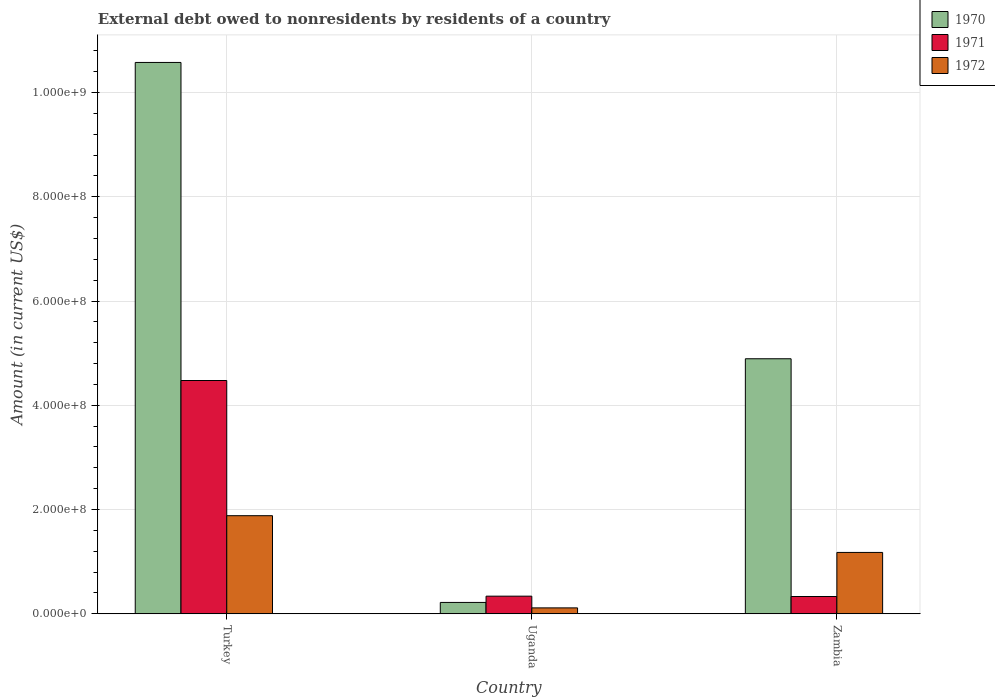How many different coloured bars are there?
Keep it short and to the point. 3. Are the number of bars on each tick of the X-axis equal?
Provide a succinct answer. Yes. What is the label of the 2nd group of bars from the left?
Your response must be concise. Uganda. What is the external debt owed by residents in 1971 in Turkey?
Offer a terse response. 4.48e+08. Across all countries, what is the maximum external debt owed by residents in 1972?
Offer a terse response. 1.88e+08. Across all countries, what is the minimum external debt owed by residents in 1970?
Keep it short and to the point. 2.18e+07. In which country was the external debt owed by residents in 1972 maximum?
Your answer should be compact. Turkey. In which country was the external debt owed by residents in 1972 minimum?
Offer a very short reply. Uganda. What is the total external debt owed by residents in 1972 in the graph?
Offer a terse response. 3.17e+08. What is the difference between the external debt owed by residents in 1971 in Turkey and that in Uganda?
Your answer should be very brief. 4.14e+08. What is the difference between the external debt owed by residents in 1971 in Zambia and the external debt owed by residents in 1970 in Uganda?
Keep it short and to the point. 1.14e+07. What is the average external debt owed by residents in 1971 per country?
Make the answer very short. 1.72e+08. What is the difference between the external debt owed by residents of/in 1970 and external debt owed by residents of/in 1971 in Uganda?
Provide a succinct answer. -1.20e+07. What is the ratio of the external debt owed by residents in 1970 in Turkey to that in Uganda?
Keep it short and to the point. 48.45. What is the difference between the highest and the second highest external debt owed by residents in 1970?
Make the answer very short. 5.68e+08. What is the difference between the highest and the lowest external debt owed by residents in 1972?
Keep it short and to the point. 1.77e+08. In how many countries, is the external debt owed by residents in 1970 greater than the average external debt owed by residents in 1970 taken over all countries?
Offer a very short reply. 1. What does the 2nd bar from the right in Zambia represents?
Your answer should be very brief. 1971. Are all the bars in the graph horizontal?
Keep it short and to the point. No. Are the values on the major ticks of Y-axis written in scientific E-notation?
Provide a short and direct response. Yes. Does the graph contain grids?
Your answer should be very brief. Yes. Where does the legend appear in the graph?
Provide a short and direct response. Top right. How many legend labels are there?
Provide a succinct answer. 3. What is the title of the graph?
Your response must be concise. External debt owed to nonresidents by residents of a country. Does "2013" appear as one of the legend labels in the graph?
Give a very brief answer. No. What is the Amount (in current US$) of 1970 in Turkey?
Give a very brief answer. 1.06e+09. What is the Amount (in current US$) of 1971 in Turkey?
Ensure brevity in your answer.  4.48e+08. What is the Amount (in current US$) in 1972 in Turkey?
Keep it short and to the point. 1.88e+08. What is the Amount (in current US$) of 1970 in Uganda?
Your answer should be compact. 2.18e+07. What is the Amount (in current US$) in 1971 in Uganda?
Offer a very short reply. 3.38e+07. What is the Amount (in current US$) in 1972 in Uganda?
Your answer should be compact. 1.14e+07. What is the Amount (in current US$) of 1970 in Zambia?
Offer a very short reply. 4.89e+08. What is the Amount (in current US$) of 1971 in Zambia?
Your response must be concise. 3.32e+07. What is the Amount (in current US$) of 1972 in Zambia?
Offer a terse response. 1.18e+08. Across all countries, what is the maximum Amount (in current US$) in 1970?
Provide a succinct answer. 1.06e+09. Across all countries, what is the maximum Amount (in current US$) in 1971?
Provide a succinct answer. 4.48e+08. Across all countries, what is the maximum Amount (in current US$) in 1972?
Provide a succinct answer. 1.88e+08. Across all countries, what is the minimum Amount (in current US$) of 1970?
Your answer should be very brief. 2.18e+07. Across all countries, what is the minimum Amount (in current US$) of 1971?
Your answer should be compact. 3.32e+07. Across all countries, what is the minimum Amount (in current US$) of 1972?
Give a very brief answer. 1.14e+07. What is the total Amount (in current US$) of 1970 in the graph?
Your response must be concise. 1.57e+09. What is the total Amount (in current US$) in 1971 in the graph?
Your response must be concise. 5.15e+08. What is the total Amount (in current US$) in 1972 in the graph?
Make the answer very short. 3.17e+08. What is the difference between the Amount (in current US$) in 1970 in Turkey and that in Uganda?
Provide a short and direct response. 1.04e+09. What is the difference between the Amount (in current US$) of 1971 in Turkey and that in Uganda?
Your response must be concise. 4.14e+08. What is the difference between the Amount (in current US$) of 1972 in Turkey and that in Uganda?
Your response must be concise. 1.77e+08. What is the difference between the Amount (in current US$) of 1970 in Turkey and that in Zambia?
Make the answer very short. 5.68e+08. What is the difference between the Amount (in current US$) of 1971 in Turkey and that in Zambia?
Your answer should be very brief. 4.14e+08. What is the difference between the Amount (in current US$) of 1972 in Turkey and that in Zambia?
Your answer should be compact. 7.05e+07. What is the difference between the Amount (in current US$) of 1970 in Uganda and that in Zambia?
Your answer should be very brief. -4.67e+08. What is the difference between the Amount (in current US$) of 1971 in Uganda and that in Zambia?
Your answer should be compact. 6.40e+05. What is the difference between the Amount (in current US$) in 1972 in Uganda and that in Zambia?
Keep it short and to the point. -1.06e+08. What is the difference between the Amount (in current US$) of 1970 in Turkey and the Amount (in current US$) of 1971 in Uganda?
Your answer should be very brief. 1.02e+09. What is the difference between the Amount (in current US$) in 1970 in Turkey and the Amount (in current US$) in 1972 in Uganda?
Make the answer very short. 1.05e+09. What is the difference between the Amount (in current US$) in 1971 in Turkey and the Amount (in current US$) in 1972 in Uganda?
Your answer should be very brief. 4.36e+08. What is the difference between the Amount (in current US$) in 1970 in Turkey and the Amount (in current US$) in 1971 in Zambia?
Your answer should be very brief. 1.02e+09. What is the difference between the Amount (in current US$) of 1970 in Turkey and the Amount (in current US$) of 1972 in Zambia?
Ensure brevity in your answer.  9.40e+08. What is the difference between the Amount (in current US$) in 1971 in Turkey and the Amount (in current US$) in 1972 in Zambia?
Keep it short and to the point. 3.30e+08. What is the difference between the Amount (in current US$) of 1970 in Uganda and the Amount (in current US$) of 1971 in Zambia?
Provide a succinct answer. -1.14e+07. What is the difference between the Amount (in current US$) of 1970 in Uganda and the Amount (in current US$) of 1972 in Zambia?
Your answer should be compact. -9.59e+07. What is the difference between the Amount (in current US$) of 1971 in Uganda and the Amount (in current US$) of 1972 in Zambia?
Make the answer very short. -8.39e+07. What is the average Amount (in current US$) of 1970 per country?
Offer a terse response. 5.23e+08. What is the average Amount (in current US$) of 1971 per country?
Offer a very short reply. 1.72e+08. What is the average Amount (in current US$) in 1972 per country?
Keep it short and to the point. 1.06e+08. What is the difference between the Amount (in current US$) of 1970 and Amount (in current US$) of 1971 in Turkey?
Make the answer very short. 6.10e+08. What is the difference between the Amount (in current US$) of 1970 and Amount (in current US$) of 1972 in Turkey?
Make the answer very short. 8.69e+08. What is the difference between the Amount (in current US$) in 1971 and Amount (in current US$) in 1972 in Turkey?
Your answer should be very brief. 2.59e+08. What is the difference between the Amount (in current US$) in 1970 and Amount (in current US$) in 1971 in Uganda?
Provide a succinct answer. -1.20e+07. What is the difference between the Amount (in current US$) in 1970 and Amount (in current US$) in 1972 in Uganda?
Your response must be concise. 1.05e+07. What is the difference between the Amount (in current US$) of 1971 and Amount (in current US$) of 1972 in Uganda?
Offer a terse response. 2.25e+07. What is the difference between the Amount (in current US$) of 1970 and Amount (in current US$) of 1971 in Zambia?
Ensure brevity in your answer.  4.56e+08. What is the difference between the Amount (in current US$) in 1970 and Amount (in current US$) in 1972 in Zambia?
Offer a very short reply. 3.72e+08. What is the difference between the Amount (in current US$) of 1971 and Amount (in current US$) of 1972 in Zambia?
Ensure brevity in your answer.  -8.45e+07. What is the ratio of the Amount (in current US$) of 1970 in Turkey to that in Uganda?
Give a very brief answer. 48.45. What is the ratio of the Amount (in current US$) in 1971 in Turkey to that in Uganda?
Your response must be concise. 13.23. What is the ratio of the Amount (in current US$) of 1972 in Turkey to that in Uganda?
Keep it short and to the point. 16.56. What is the ratio of the Amount (in current US$) in 1970 in Turkey to that in Zambia?
Keep it short and to the point. 2.16. What is the ratio of the Amount (in current US$) of 1971 in Turkey to that in Zambia?
Give a very brief answer. 13.48. What is the ratio of the Amount (in current US$) in 1972 in Turkey to that in Zambia?
Ensure brevity in your answer.  1.6. What is the ratio of the Amount (in current US$) of 1970 in Uganda to that in Zambia?
Offer a very short reply. 0.04. What is the ratio of the Amount (in current US$) in 1971 in Uganda to that in Zambia?
Offer a terse response. 1.02. What is the ratio of the Amount (in current US$) of 1972 in Uganda to that in Zambia?
Provide a succinct answer. 0.1. What is the difference between the highest and the second highest Amount (in current US$) in 1970?
Your response must be concise. 5.68e+08. What is the difference between the highest and the second highest Amount (in current US$) of 1971?
Provide a short and direct response. 4.14e+08. What is the difference between the highest and the second highest Amount (in current US$) of 1972?
Ensure brevity in your answer.  7.05e+07. What is the difference between the highest and the lowest Amount (in current US$) of 1970?
Give a very brief answer. 1.04e+09. What is the difference between the highest and the lowest Amount (in current US$) of 1971?
Make the answer very short. 4.14e+08. What is the difference between the highest and the lowest Amount (in current US$) in 1972?
Provide a succinct answer. 1.77e+08. 